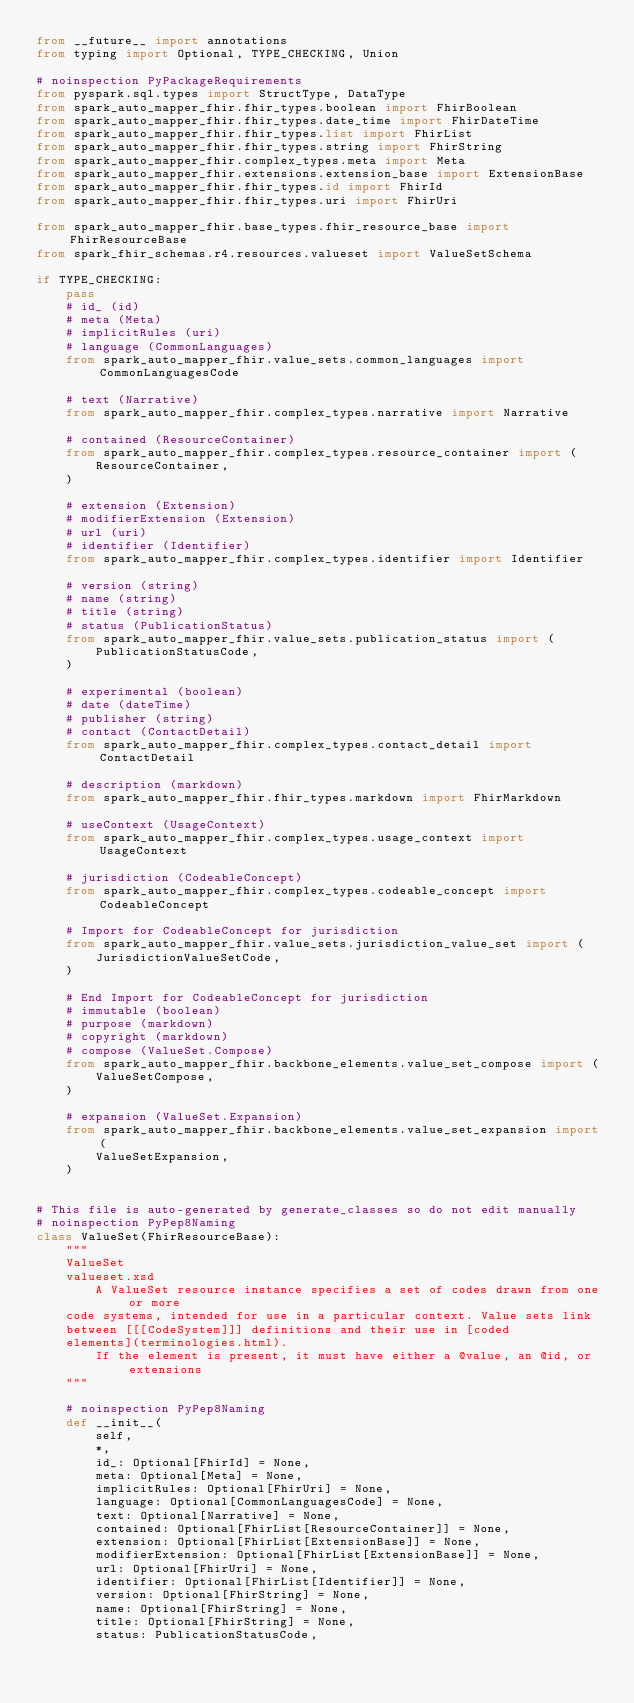<code> <loc_0><loc_0><loc_500><loc_500><_Python_>from __future__ import annotations
from typing import Optional, TYPE_CHECKING, Union

# noinspection PyPackageRequirements
from pyspark.sql.types import StructType, DataType
from spark_auto_mapper_fhir.fhir_types.boolean import FhirBoolean
from spark_auto_mapper_fhir.fhir_types.date_time import FhirDateTime
from spark_auto_mapper_fhir.fhir_types.list import FhirList
from spark_auto_mapper_fhir.fhir_types.string import FhirString
from spark_auto_mapper_fhir.complex_types.meta import Meta
from spark_auto_mapper_fhir.extensions.extension_base import ExtensionBase
from spark_auto_mapper_fhir.fhir_types.id import FhirId
from spark_auto_mapper_fhir.fhir_types.uri import FhirUri

from spark_auto_mapper_fhir.base_types.fhir_resource_base import FhirResourceBase
from spark_fhir_schemas.r4.resources.valueset import ValueSetSchema

if TYPE_CHECKING:
    pass
    # id_ (id)
    # meta (Meta)
    # implicitRules (uri)
    # language (CommonLanguages)
    from spark_auto_mapper_fhir.value_sets.common_languages import CommonLanguagesCode

    # text (Narrative)
    from spark_auto_mapper_fhir.complex_types.narrative import Narrative

    # contained (ResourceContainer)
    from spark_auto_mapper_fhir.complex_types.resource_container import (
        ResourceContainer,
    )

    # extension (Extension)
    # modifierExtension (Extension)
    # url (uri)
    # identifier (Identifier)
    from spark_auto_mapper_fhir.complex_types.identifier import Identifier

    # version (string)
    # name (string)
    # title (string)
    # status (PublicationStatus)
    from spark_auto_mapper_fhir.value_sets.publication_status import (
        PublicationStatusCode,
    )

    # experimental (boolean)
    # date (dateTime)
    # publisher (string)
    # contact (ContactDetail)
    from spark_auto_mapper_fhir.complex_types.contact_detail import ContactDetail

    # description (markdown)
    from spark_auto_mapper_fhir.fhir_types.markdown import FhirMarkdown

    # useContext (UsageContext)
    from spark_auto_mapper_fhir.complex_types.usage_context import UsageContext

    # jurisdiction (CodeableConcept)
    from spark_auto_mapper_fhir.complex_types.codeable_concept import CodeableConcept

    # Import for CodeableConcept for jurisdiction
    from spark_auto_mapper_fhir.value_sets.jurisdiction_value_set import (
        JurisdictionValueSetCode,
    )

    # End Import for CodeableConcept for jurisdiction
    # immutable (boolean)
    # purpose (markdown)
    # copyright (markdown)
    # compose (ValueSet.Compose)
    from spark_auto_mapper_fhir.backbone_elements.value_set_compose import (
        ValueSetCompose,
    )

    # expansion (ValueSet.Expansion)
    from spark_auto_mapper_fhir.backbone_elements.value_set_expansion import (
        ValueSetExpansion,
    )


# This file is auto-generated by generate_classes so do not edit manually
# noinspection PyPep8Naming
class ValueSet(FhirResourceBase):
    """
    ValueSet
    valueset.xsd
        A ValueSet resource instance specifies a set of codes drawn from one or more
    code systems, intended for use in a particular context. Value sets link
    between [[[CodeSystem]]] definitions and their use in [coded
    elements](terminologies.html).
        If the element is present, it must have either a @value, an @id, or extensions
    """

    # noinspection PyPep8Naming
    def __init__(
        self,
        *,
        id_: Optional[FhirId] = None,
        meta: Optional[Meta] = None,
        implicitRules: Optional[FhirUri] = None,
        language: Optional[CommonLanguagesCode] = None,
        text: Optional[Narrative] = None,
        contained: Optional[FhirList[ResourceContainer]] = None,
        extension: Optional[FhirList[ExtensionBase]] = None,
        modifierExtension: Optional[FhirList[ExtensionBase]] = None,
        url: Optional[FhirUri] = None,
        identifier: Optional[FhirList[Identifier]] = None,
        version: Optional[FhirString] = None,
        name: Optional[FhirString] = None,
        title: Optional[FhirString] = None,
        status: PublicationStatusCode,</code> 